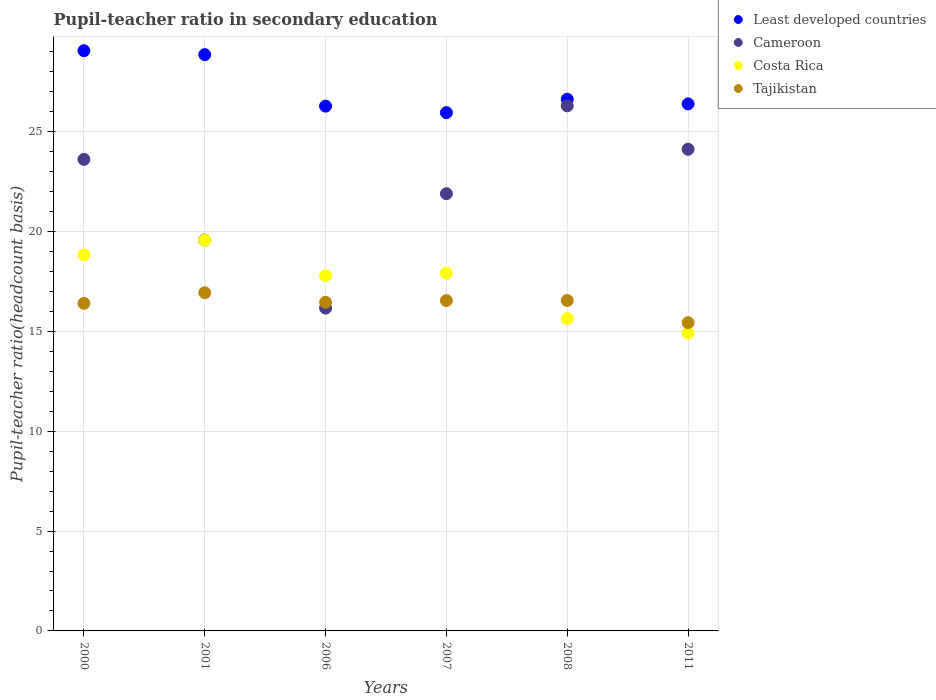What is the pupil-teacher ratio in secondary education in Least developed countries in 2006?
Give a very brief answer. 26.28. Across all years, what is the maximum pupil-teacher ratio in secondary education in Costa Rica?
Your answer should be compact. 19.57. Across all years, what is the minimum pupil-teacher ratio in secondary education in Tajikistan?
Provide a short and direct response. 15.44. In which year was the pupil-teacher ratio in secondary education in Least developed countries maximum?
Ensure brevity in your answer.  2000. In which year was the pupil-teacher ratio in secondary education in Tajikistan minimum?
Make the answer very short. 2011. What is the total pupil-teacher ratio in secondary education in Cameroon in the graph?
Your answer should be compact. 131.69. What is the difference between the pupil-teacher ratio in secondary education in Tajikistan in 2000 and that in 2001?
Give a very brief answer. -0.53. What is the difference between the pupil-teacher ratio in secondary education in Costa Rica in 2011 and the pupil-teacher ratio in secondary education in Cameroon in 2000?
Your answer should be compact. -8.7. What is the average pupil-teacher ratio in secondary education in Tajikistan per year?
Provide a succinct answer. 16.39. In the year 2008, what is the difference between the pupil-teacher ratio in secondary education in Least developed countries and pupil-teacher ratio in secondary education in Tajikistan?
Give a very brief answer. 10.08. In how many years, is the pupil-teacher ratio in secondary education in Cameroon greater than 12?
Give a very brief answer. 6. What is the ratio of the pupil-teacher ratio in secondary education in Tajikistan in 2000 to that in 2006?
Make the answer very short. 1. Is the pupil-teacher ratio in secondary education in Tajikistan in 2006 less than that in 2008?
Ensure brevity in your answer.  Yes. What is the difference between the highest and the second highest pupil-teacher ratio in secondary education in Tajikistan?
Your response must be concise. 0.39. What is the difference between the highest and the lowest pupil-teacher ratio in secondary education in Least developed countries?
Your answer should be very brief. 3.1. In how many years, is the pupil-teacher ratio in secondary education in Tajikistan greater than the average pupil-teacher ratio in secondary education in Tajikistan taken over all years?
Your answer should be very brief. 5. Is the pupil-teacher ratio in secondary education in Cameroon strictly greater than the pupil-teacher ratio in secondary education in Least developed countries over the years?
Ensure brevity in your answer.  No. How many dotlines are there?
Your response must be concise. 4. What is the difference between two consecutive major ticks on the Y-axis?
Your answer should be compact. 5. Does the graph contain grids?
Your answer should be very brief. Yes. Where does the legend appear in the graph?
Offer a terse response. Top right. What is the title of the graph?
Make the answer very short. Pupil-teacher ratio in secondary education. What is the label or title of the X-axis?
Make the answer very short. Years. What is the label or title of the Y-axis?
Your response must be concise. Pupil-teacher ratio(headcount basis). What is the Pupil-teacher ratio(headcount basis) of Least developed countries in 2000?
Offer a terse response. 29.06. What is the Pupil-teacher ratio(headcount basis) of Cameroon in 2000?
Keep it short and to the point. 23.62. What is the Pupil-teacher ratio(headcount basis) of Costa Rica in 2000?
Ensure brevity in your answer.  18.84. What is the Pupil-teacher ratio(headcount basis) in Tajikistan in 2000?
Offer a very short reply. 16.41. What is the Pupil-teacher ratio(headcount basis) in Least developed countries in 2001?
Make the answer very short. 28.86. What is the Pupil-teacher ratio(headcount basis) of Cameroon in 2001?
Your response must be concise. 19.58. What is the Pupil-teacher ratio(headcount basis) in Costa Rica in 2001?
Keep it short and to the point. 19.57. What is the Pupil-teacher ratio(headcount basis) of Tajikistan in 2001?
Provide a short and direct response. 16.94. What is the Pupil-teacher ratio(headcount basis) of Least developed countries in 2006?
Offer a very short reply. 26.28. What is the Pupil-teacher ratio(headcount basis) of Cameroon in 2006?
Provide a short and direct response. 16.17. What is the Pupil-teacher ratio(headcount basis) in Costa Rica in 2006?
Your answer should be very brief. 17.79. What is the Pupil-teacher ratio(headcount basis) in Tajikistan in 2006?
Your answer should be very brief. 16.46. What is the Pupil-teacher ratio(headcount basis) of Least developed countries in 2007?
Offer a terse response. 25.96. What is the Pupil-teacher ratio(headcount basis) of Cameroon in 2007?
Your answer should be very brief. 21.9. What is the Pupil-teacher ratio(headcount basis) in Costa Rica in 2007?
Provide a short and direct response. 17.91. What is the Pupil-teacher ratio(headcount basis) of Tajikistan in 2007?
Provide a succinct answer. 16.54. What is the Pupil-teacher ratio(headcount basis) of Least developed countries in 2008?
Provide a succinct answer. 26.63. What is the Pupil-teacher ratio(headcount basis) of Cameroon in 2008?
Offer a terse response. 26.3. What is the Pupil-teacher ratio(headcount basis) in Costa Rica in 2008?
Your response must be concise. 15.64. What is the Pupil-teacher ratio(headcount basis) of Tajikistan in 2008?
Your answer should be very brief. 16.55. What is the Pupil-teacher ratio(headcount basis) in Least developed countries in 2011?
Make the answer very short. 26.4. What is the Pupil-teacher ratio(headcount basis) in Cameroon in 2011?
Your answer should be very brief. 24.13. What is the Pupil-teacher ratio(headcount basis) in Costa Rica in 2011?
Your answer should be compact. 14.92. What is the Pupil-teacher ratio(headcount basis) of Tajikistan in 2011?
Keep it short and to the point. 15.44. Across all years, what is the maximum Pupil-teacher ratio(headcount basis) of Least developed countries?
Provide a succinct answer. 29.06. Across all years, what is the maximum Pupil-teacher ratio(headcount basis) of Cameroon?
Offer a terse response. 26.3. Across all years, what is the maximum Pupil-teacher ratio(headcount basis) of Costa Rica?
Make the answer very short. 19.57. Across all years, what is the maximum Pupil-teacher ratio(headcount basis) of Tajikistan?
Give a very brief answer. 16.94. Across all years, what is the minimum Pupil-teacher ratio(headcount basis) in Least developed countries?
Provide a succinct answer. 25.96. Across all years, what is the minimum Pupil-teacher ratio(headcount basis) of Cameroon?
Your response must be concise. 16.17. Across all years, what is the minimum Pupil-teacher ratio(headcount basis) in Costa Rica?
Provide a short and direct response. 14.92. Across all years, what is the minimum Pupil-teacher ratio(headcount basis) of Tajikistan?
Your answer should be very brief. 15.44. What is the total Pupil-teacher ratio(headcount basis) of Least developed countries in the graph?
Your answer should be compact. 163.2. What is the total Pupil-teacher ratio(headcount basis) in Cameroon in the graph?
Offer a very short reply. 131.69. What is the total Pupil-teacher ratio(headcount basis) in Costa Rica in the graph?
Provide a short and direct response. 104.68. What is the total Pupil-teacher ratio(headcount basis) in Tajikistan in the graph?
Your response must be concise. 98.34. What is the difference between the Pupil-teacher ratio(headcount basis) of Least developed countries in 2000 and that in 2001?
Your answer should be very brief. 0.2. What is the difference between the Pupil-teacher ratio(headcount basis) of Cameroon in 2000 and that in 2001?
Provide a succinct answer. 4.04. What is the difference between the Pupil-teacher ratio(headcount basis) in Costa Rica in 2000 and that in 2001?
Offer a terse response. -0.73. What is the difference between the Pupil-teacher ratio(headcount basis) in Tajikistan in 2000 and that in 2001?
Provide a succinct answer. -0.53. What is the difference between the Pupil-teacher ratio(headcount basis) in Least developed countries in 2000 and that in 2006?
Offer a very short reply. 2.78. What is the difference between the Pupil-teacher ratio(headcount basis) in Cameroon in 2000 and that in 2006?
Your answer should be very brief. 7.45. What is the difference between the Pupil-teacher ratio(headcount basis) in Costa Rica in 2000 and that in 2006?
Your answer should be compact. 1.05. What is the difference between the Pupil-teacher ratio(headcount basis) of Tajikistan in 2000 and that in 2006?
Provide a succinct answer. -0.05. What is the difference between the Pupil-teacher ratio(headcount basis) of Least developed countries in 2000 and that in 2007?
Make the answer very short. 3.1. What is the difference between the Pupil-teacher ratio(headcount basis) in Cameroon in 2000 and that in 2007?
Your answer should be compact. 1.72. What is the difference between the Pupil-teacher ratio(headcount basis) of Costa Rica in 2000 and that in 2007?
Keep it short and to the point. 0.93. What is the difference between the Pupil-teacher ratio(headcount basis) in Tajikistan in 2000 and that in 2007?
Your response must be concise. -0.14. What is the difference between the Pupil-teacher ratio(headcount basis) in Least developed countries in 2000 and that in 2008?
Ensure brevity in your answer.  2.43. What is the difference between the Pupil-teacher ratio(headcount basis) of Cameroon in 2000 and that in 2008?
Offer a very short reply. -2.68. What is the difference between the Pupil-teacher ratio(headcount basis) in Costa Rica in 2000 and that in 2008?
Make the answer very short. 3.2. What is the difference between the Pupil-teacher ratio(headcount basis) of Tajikistan in 2000 and that in 2008?
Provide a short and direct response. -0.14. What is the difference between the Pupil-teacher ratio(headcount basis) of Least developed countries in 2000 and that in 2011?
Make the answer very short. 2.66. What is the difference between the Pupil-teacher ratio(headcount basis) of Cameroon in 2000 and that in 2011?
Your response must be concise. -0.51. What is the difference between the Pupil-teacher ratio(headcount basis) of Costa Rica in 2000 and that in 2011?
Your answer should be compact. 3.92. What is the difference between the Pupil-teacher ratio(headcount basis) of Tajikistan in 2000 and that in 2011?
Provide a succinct answer. 0.97. What is the difference between the Pupil-teacher ratio(headcount basis) in Least developed countries in 2001 and that in 2006?
Your answer should be compact. 2.58. What is the difference between the Pupil-teacher ratio(headcount basis) of Cameroon in 2001 and that in 2006?
Keep it short and to the point. 3.41. What is the difference between the Pupil-teacher ratio(headcount basis) in Costa Rica in 2001 and that in 2006?
Provide a short and direct response. 1.78. What is the difference between the Pupil-teacher ratio(headcount basis) in Tajikistan in 2001 and that in 2006?
Provide a succinct answer. 0.48. What is the difference between the Pupil-teacher ratio(headcount basis) in Least developed countries in 2001 and that in 2007?
Make the answer very short. 2.9. What is the difference between the Pupil-teacher ratio(headcount basis) in Cameroon in 2001 and that in 2007?
Make the answer very short. -2.32. What is the difference between the Pupil-teacher ratio(headcount basis) of Costa Rica in 2001 and that in 2007?
Offer a very short reply. 1.66. What is the difference between the Pupil-teacher ratio(headcount basis) of Tajikistan in 2001 and that in 2007?
Ensure brevity in your answer.  0.4. What is the difference between the Pupil-teacher ratio(headcount basis) of Least developed countries in 2001 and that in 2008?
Give a very brief answer. 2.23. What is the difference between the Pupil-teacher ratio(headcount basis) of Cameroon in 2001 and that in 2008?
Provide a succinct answer. -6.72. What is the difference between the Pupil-teacher ratio(headcount basis) in Costa Rica in 2001 and that in 2008?
Ensure brevity in your answer.  3.93. What is the difference between the Pupil-teacher ratio(headcount basis) of Tajikistan in 2001 and that in 2008?
Give a very brief answer. 0.39. What is the difference between the Pupil-teacher ratio(headcount basis) of Least developed countries in 2001 and that in 2011?
Provide a short and direct response. 2.47. What is the difference between the Pupil-teacher ratio(headcount basis) of Cameroon in 2001 and that in 2011?
Offer a very short reply. -4.55. What is the difference between the Pupil-teacher ratio(headcount basis) of Costa Rica in 2001 and that in 2011?
Your response must be concise. 4.65. What is the difference between the Pupil-teacher ratio(headcount basis) in Tajikistan in 2001 and that in 2011?
Offer a very short reply. 1.5. What is the difference between the Pupil-teacher ratio(headcount basis) in Least developed countries in 2006 and that in 2007?
Your answer should be very brief. 0.33. What is the difference between the Pupil-teacher ratio(headcount basis) of Cameroon in 2006 and that in 2007?
Offer a very short reply. -5.73. What is the difference between the Pupil-teacher ratio(headcount basis) of Costa Rica in 2006 and that in 2007?
Offer a terse response. -0.12. What is the difference between the Pupil-teacher ratio(headcount basis) of Tajikistan in 2006 and that in 2007?
Offer a terse response. -0.09. What is the difference between the Pupil-teacher ratio(headcount basis) of Least developed countries in 2006 and that in 2008?
Your answer should be compact. -0.35. What is the difference between the Pupil-teacher ratio(headcount basis) of Cameroon in 2006 and that in 2008?
Your response must be concise. -10.13. What is the difference between the Pupil-teacher ratio(headcount basis) of Costa Rica in 2006 and that in 2008?
Ensure brevity in your answer.  2.15. What is the difference between the Pupil-teacher ratio(headcount basis) of Tajikistan in 2006 and that in 2008?
Your answer should be very brief. -0.09. What is the difference between the Pupil-teacher ratio(headcount basis) in Least developed countries in 2006 and that in 2011?
Your answer should be compact. -0.11. What is the difference between the Pupil-teacher ratio(headcount basis) in Cameroon in 2006 and that in 2011?
Make the answer very short. -7.96. What is the difference between the Pupil-teacher ratio(headcount basis) of Costa Rica in 2006 and that in 2011?
Keep it short and to the point. 2.87. What is the difference between the Pupil-teacher ratio(headcount basis) of Least developed countries in 2007 and that in 2008?
Your response must be concise. -0.67. What is the difference between the Pupil-teacher ratio(headcount basis) of Cameroon in 2007 and that in 2008?
Make the answer very short. -4.4. What is the difference between the Pupil-teacher ratio(headcount basis) of Costa Rica in 2007 and that in 2008?
Offer a very short reply. 2.27. What is the difference between the Pupil-teacher ratio(headcount basis) of Tajikistan in 2007 and that in 2008?
Give a very brief answer. -0.01. What is the difference between the Pupil-teacher ratio(headcount basis) of Least developed countries in 2007 and that in 2011?
Offer a very short reply. -0.44. What is the difference between the Pupil-teacher ratio(headcount basis) in Cameroon in 2007 and that in 2011?
Provide a short and direct response. -2.23. What is the difference between the Pupil-teacher ratio(headcount basis) in Costa Rica in 2007 and that in 2011?
Offer a very short reply. 2.99. What is the difference between the Pupil-teacher ratio(headcount basis) of Tajikistan in 2007 and that in 2011?
Keep it short and to the point. 1.11. What is the difference between the Pupil-teacher ratio(headcount basis) in Least developed countries in 2008 and that in 2011?
Your response must be concise. 0.23. What is the difference between the Pupil-teacher ratio(headcount basis) in Cameroon in 2008 and that in 2011?
Make the answer very short. 2.18. What is the difference between the Pupil-teacher ratio(headcount basis) of Costa Rica in 2008 and that in 2011?
Provide a succinct answer. 0.72. What is the difference between the Pupil-teacher ratio(headcount basis) of Tajikistan in 2008 and that in 2011?
Your answer should be very brief. 1.11. What is the difference between the Pupil-teacher ratio(headcount basis) of Least developed countries in 2000 and the Pupil-teacher ratio(headcount basis) of Cameroon in 2001?
Give a very brief answer. 9.48. What is the difference between the Pupil-teacher ratio(headcount basis) in Least developed countries in 2000 and the Pupil-teacher ratio(headcount basis) in Costa Rica in 2001?
Offer a very short reply. 9.49. What is the difference between the Pupil-teacher ratio(headcount basis) of Least developed countries in 2000 and the Pupil-teacher ratio(headcount basis) of Tajikistan in 2001?
Ensure brevity in your answer.  12.12. What is the difference between the Pupil-teacher ratio(headcount basis) of Cameroon in 2000 and the Pupil-teacher ratio(headcount basis) of Costa Rica in 2001?
Ensure brevity in your answer.  4.05. What is the difference between the Pupil-teacher ratio(headcount basis) of Cameroon in 2000 and the Pupil-teacher ratio(headcount basis) of Tajikistan in 2001?
Keep it short and to the point. 6.68. What is the difference between the Pupil-teacher ratio(headcount basis) in Costa Rica in 2000 and the Pupil-teacher ratio(headcount basis) in Tajikistan in 2001?
Give a very brief answer. 1.9. What is the difference between the Pupil-teacher ratio(headcount basis) in Least developed countries in 2000 and the Pupil-teacher ratio(headcount basis) in Cameroon in 2006?
Ensure brevity in your answer.  12.89. What is the difference between the Pupil-teacher ratio(headcount basis) of Least developed countries in 2000 and the Pupil-teacher ratio(headcount basis) of Costa Rica in 2006?
Your response must be concise. 11.27. What is the difference between the Pupil-teacher ratio(headcount basis) of Least developed countries in 2000 and the Pupil-teacher ratio(headcount basis) of Tajikistan in 2006?
Your response must be concise. 12.6. What is the difference between the Pupil-teacher ratio(headcount basis) in Cameroon in 2000 and the Pupil-teacher ratio(headcount basis) in Costa Rica in 2006?
Make the answer very short. 5.82. What is the difference between the Pupil-teacher ratio(headcount basis) in Cameroon in 2000 and the Pupil-teacher ratio(headcount basis) in Tajikistan in 2006?
Offer a terse response. 7.16. What is the difference between the Pupil-teacher ratio(headcount basis) in Costa Rica in 2000 and the Pupil-teacher ratio(headcount basis) in Tajikistan in 2006?
Your response must be concise. 2.38. What is the difference between the Pupil-teacher ratio(headcount basis) in Least developed countries in 2000 and the Pupil-teacher ratio(headcount basis) in Cameroon in 2007?
Provide a short and direct response. 7.16. What is the difference between the Pupil-teacher ratio(headcount basis) in Least developed countries in 2000 and the Pupil-teacher ratio(headcount basis) in Costa Rica in 2007?
Provide a short and direct response. 11.15. What is the difference between the Pupil-teacher ratio(headcount basis) of Least developed countries in 2000 and the Pupil-teacher ratio(headcount basis) of Tajikistan in 2007?
Your answer should be compact. 12.52. What is the difference between the Pupil-teacher ratio(headcount basis) in Cameroon in 2000 and the Pupil-teacher ratio(headcount basis) in Costa Rica in 2007?
Keep it short and to the point. 5.71. What is the difference between the Pupil-teacher ratio(headcount basis) in Cameroon in 2000 and the Pupil-teacher ratio(headcount basis) in Tajikistan in 2007?
Your answer should be very brief. 7.07. What is the difference between the Pupil-teacher ratio(headcount basis) of Costa Rica in 2000 and the Pupil-teacher ratio(headcount basis) of Tajikistan in 2007?
Make the answer very short. 2.3. What is the difference between the Pupil-teacher ratio(headcount basis) of Least developed countries in 2000 and the Pupil-teacher ratio(headcount basis) of Cameroon in 2008?
Make the answer very short. 2.76. What is the difference between the Pupil-teacher ratio(headcount basis) of Least developed countries in 2000 and the Pupil-teacher ratio(headcount basis) of Costa Rica in 2008?
Keep it short and to the point. 13.42. What is the difference between the Pupil-teacher ratio(headcount basis) of Least developed countries in 2000 and the Pupil-teacher ratio(headcount basis) of Tajikistan in 2008?
Provide a succinct answer. 12.51. What is the difference between the Pupil-teacher ratio(headcount basis) in Cameroon in 2000 and the Pupil-teacher ratio(headcount basis) in Costa Rica in 2008?
Your answer should be compact. 7.98. What is the difference between the Pupil-teacher ratio(headcount basis) of Cameroon in 2000 and the Pupil-teacher ratio(headcount basis) of Tajikistan in 2008?
Give a very brief answer. 7.07. What is the difference between the Pupil-teacher ratio(headcount basis) in Costa Rica in 2000 and the Pupil-teacher ratio(headcount basis) in Tajikistan in 2008?
Make the answer very short. 2.29. What is the difference between the Pupil-teacher ratio(headcount basis) in Least developed countries in 2000 and the Pupil-teacher ratio(headcount basis) in Cameroon in 2011?
Provide a short and direct response. 4.94. What is the difference between the Pupil-teacher ratio(headcount basis) of Least developed countries in 2000 and the Pupil-teacher ratio(headcount basis) of Costa Rica in 2011?
Ensure brevity in your answer.  14.14. What is the difference between the Pupil-teacher ratio(headcount basis) in Least developed countries in 2000 and the Pupil-teacher ratio(headcount basis) in Tajikistan in 2011?
Provide a short and direct response. 13.62. What is the difference between the Pupil-teacher ratio(headcount basis) in Cameroon in 2000 and the Pupil-teacher ratio(headcount basis) in Costa Rica in 2011?
Make the answer very short. 8.7. What is the difference between the Pupil-teacher ratio(headcount basis) of Cameroon in 2000 and the Pupil-teacher ratio(headcount basis) of Tajikistan in 2011?
Offer a terse response. 8.18. What is the difference between the Pupil-teacher ratio(headcount basis) of Costa Rica in 2000 and the Pupil-teacher ratio(headcount basis) of Tajikistan in 2011?
Provide a short and direct response. 3.4. What is the difference between the Pupil-teacher ratio(headcount basis) of Least developed countries in 2001 and the Pupil-teacher ratio(headcount basis) of Cameroon in 2006?
Your answer should be compact. 12.69. What is the difference between the Pupil-teacher ratio(headcount basis) in Least developed countries in 2001 and the Pupil-teacher ratio(headcount basis) in Costa Rica in 2006?
Your answer should be compact. 11.07. What is the difference between the Pupil-teacher ratio(headcount basis) of Least developed countries in 2001 and the Pupil-teacher ratio(headcount basis) of Tajikistan in 2006?
Give a very brief answer. 12.41. What is the difference between the Pupil-teacher ratio(headcount basis) of Cameroon in 2001 and the Pupil-teacher ratio(headcount basis) of Costa Rica in 2006?
Ensure brevity in your answer.  1.78. What is the difference between the Pupil-teacher ratio(headcount basis) in Cameroon in 2001 and the Pupil-teacher ratio(headcount basis) in Tajikistan in 2006?
Keep it short and to the point. 3.12. What is the difference between the Pupil-teacher ratio(headcount basis) of Costa Rica in 2001 and the Pupil-teacher ratio(headcount basis) of Tajikistan in 2006?
Offer a terse response. 3.11. What is the difference between the Pupil-teacher ratio(headcount basis) of Least developed countries in 2001 and the Pupil-teacher ratio(headcount basis) of Cameroon in 2007?
Ensure brevity in your answer.  6.97. What is the difference between the Pupil-teacher ratio(headcount basis) in Least developed countries in 2001 and the Pupil-teacher ratio(headcount basis) in Costa Rica in 2007?
Ensure brevity in your answer.  10.95. What is the difference between the Pupil-teacher ratio(headcount basis) in Least developed countries in 2001 and the Pupil-teacher ratio(headcount basis) in Tajikistan in 2007?
Offer a very short reply. 12.32. What is the difference between the Pupil-teacher ratio(headcount basis) of Cameroon in 2001 and the Pupil-teacher ratio(headcount basis) of Costa Rica in 2007?
Offer a terse response. 1.67. What is the difference between the Pupil-teacher ratio(headcount basis) of Cameroon in 2001 and the Pupil-teacher ratio(headcount basis) of Tajikistan in 2007?
Provide a succinct answer. 3.03. What is the difference between the Pupil-teacher ratio(headcount basis) of Costa Rica in 2001 and the Pupil-teacher ratio(headcount basis) of Tajikistan in 2007?
Your answer should be compact. 3.03. What is the difference between the Pupil-teacher ratio(headcount basis) of Least developed countries in 2001 and the Pupil-teacher ratio(headcount basis) of Cameroon in 2008?
Provide a short and direct response. 2.56. What is the difference between the Pupil-teacher ratio(headcount basis) in Least developed countries in 2001 and the Pupil-teacher ratio(headcount basis) in Costa Rica in 2008?
Your response must be concise. 13.22. What is the difference between the Pupil-teacher ratio(headcount basis) of Least developed countries in 2001 and the Pupil-teacher ratio(headcount basis) of Tajikistan in 2008?
Your answer should be very brief. 12.31. What is the difference between the Pupil-teacher ratio(headcount basis) of Cameroon in 2001 and the Pupil-teacher ratio(headcount basis) of Costa Rica in 2008?
Ensure brevity in your answer.  3.94. What is the difference between the Pupil-teacher ratio(headcount basis) of Cameroon in 2001 and the Pupil-teacher ratio(headcount basis) of Tajikistan in 2008?
Offer a terse response. 3.03. What is the difference between the Pupil-teacher ratio(headcount basis) of Costa Rica in 2001 and the Pupil-teacher ratio(headcount basis) of Tajikistan in 2008?
Provide a short and direct response. 3.02. What is the difference between the Pupil-teacher ratio(headcount basis) in Least developed countries in 2001 and the Pupil-teacher ratio(headcount basis) in Cameroon in 2011?
Provide a succinct answer. 4.74. What is the difference between the Pupil-teacher ratio(headcount basis) in Least developed countries in 2001 and the Pupil-teacher ratio(headcount basis) in Costa Rica in 2011?
Your response must be concise. 13.94. What is the difference between the Pupil-teacher ratio(headcount basis) in Least developed countries in 2001 and the Pupil-teacher ratio(headcount basis) in Tajikistan in 2011?
Give a very brief answer. 13.43. What is the difference between the Pupil-teacher ratio(headcount basis) in Cameroon in 2001 and the Pupil-teacher ratio(headcount basis) in Costa Rica in 2011?
Provide a succinct answer. 4.66. What is the difference between the Pupil-teacher ratio(headcount basis) in Cameroon in 2001 and the Pupil-teacher ratio(headcount basis) in Tajikistan in 2011?
Your response must be concise. 4.14. What is the difference between the Pupil-teacher ratio(headcount basis) of Costa Rica in 2001 and the Pupil-teacher ratio(headcount basis) of Tajikistan in 2011?
Give a very brief answer. 4.13. What is the difference between the Pupil-teacher ratio(headcount basis) in Least developed countries in 2006 and the Pupil-teacher ratio(headcount basis) in Cameroon in 2007?
Ensure brevity in your answer.  4.39. What is the difference between the Pupil-teacher ratio(headcount basis) of Least developed countries in 2006 and the Pupil-teacher ratio(headcount basis) of Costa Rica in 2007?
Your answer should be very brief. 8.37. What is the difference between the Pupil-teacher ratio(headcount basis) in Least developed countries in 2006 and the Pupil-teacher ratio(headcount basis) in Tajikistan in 2007?
Ensure brevity in your answer.  9.74. What is the difference between the Pupil-teacher ratio(headcount basis) in Cameroon in 2006 and the Pupil-teacher ratio(headcount basis) in Costa Rica in 2007?
Your answer should be compact. -1.74. What is the difference between the Pupil-teacher ratio(headcount basis) in Cameroon in 2006 and the Pupil-teacher ratio(headcount basis) in Tajikistan in 2007?
Your response must be concise. -0.37. What is the difference between the Pupil-teacher ratio(headcount basis) of Costa Rica in 2006 and the Pupil-teacher ratio(headcount basis) of Tajikistan in 2007?
Make the answer very short. 1.25. What is the difference between the Pupil-teacher ratio(headcount basis) in Least developed countries in 2006 and the Pupil-teacher ratio(headcount basis) in Cameroon in 2008?
Offer a very short reply. -0.02. What is the difference between the Pupil-teacher ratio(headcount basis) of Least developed countries in 2006 and the Pupil-teacher ratio(headcount basis) of Costa Rica in 2008?
Offer a terse response. 10.64. What is the difference between the Pupil-teacher ratio(headcount basis) in Least developed countries in 2006 and the Pupil-teacher ratio(headcount basis) in Tajikistan in 2008?
Make the answer very short. 9.73. What is the difference between the Pupil-teacher ratio(headcount basis) in Cameroon in 2006 and the Pupil-teacher ratio(headcount basis) in Costa Rica in 2008?
Your answer should be very brief. 0.53. What is the difference between the Pupil-teacher ratio(headcount basis) of Cameroon in 2006 and the Pupil-teacher ratio(headcount basis) of Tajikistan in 2008?
Offer a very short reply. -0.38. What is the difference between the Pupil-teacher ratio(headcount basis) of Costa Rica in 2006 and the Pupil-teacher ratio(headcount basis) of Tajikistan in 2008?
Your response must be concise. 1.24. What is the difference between the Pupil-teacher ratio(headcount basis) in Least developed countries in 2006 and the Pupil-teacher ratio(headcount basis) in Cameroon in 2011?
Provide a short and direct response. 2.16. What is the difference between the Pupil-teacher ratio(headcount basis) of Least developed countries in 2006 and the Pupil-teacher ratio(headcount basis) of Costa Rica in 2011?
Your answer should be compact. 11.36. What is the difference between the Pupil-teacher ratio(headcount basis) of Least developed countries in 2006 and the Pupil-teacher ratio(headcount basis) of Tajikistan in 2011?
Provide a short and direct response. 10.85. What is the difference between the Pupil-teacher ratio(headcount basis) in Cameroon in 2006 and the Pupil-teacher ratio(headcount basis) in Costa Rica in 2011?
Your response must be concise. 1.25. What is the difference between the Pupil-teacher ratio(headcount basis) in Cameroon in 2006 and the Pupil-teacher ratio(headcount basis) in Tajikistan in 2011?
Keep it short and to the point. 0.73. What is the difference between the Pupil-teacher ratio(headcount basis) in Costa Rica in 2006 and the Pupil-teacher ratio(headcount basis) in Tajikistan in 2011?
Keep it short and to the point. 2.36. What is the difference between the Pupil-teacher ratio(headcount basis) in Least developed countries in 2007 and the Pupil-teacher ratio(headcount basis) in Cameroon in 2008?
Give a very brief answer. -0.34. What is the difference between the Pupil-teacher ratio(headcount basis) in Least developed countries in 2007 and the Pupil-teacher ratio(headcount basis) in Costa Rica in 2008?
Give a very brief answer. 10.32. What is the difference between the Pupil-teacher ratio(headcount basis) in Least developed countries in 2007 and the Pupil-teacher ratio(headcount basis) in Tajikistan in 2008?
Keep it short and to the point. 9.41. What is the difference between the Pupil-teacher ratio(headcount basis) of Cameroon in 2007 and the Pupil-teacher ratio(headcount basis) of Costa Rica in 2008?
Your response must be concise. 6.26. What is the difference between the Pupil-teacher ratio(headcount basis) of Cameroon in 2007 and the Pupil-teacher ratio(headcount basis) of Tajikistan in 2008?
Your answer should be compact. 5.35. What is the difference between the Pupil-teacher ratio(headcount basis) in Costa Rica in 2007 and the Pupil-teacher ratio(headcount basis) in Tajikistan in 2008?
Keep it short and to the point. 1.36. What is the difference between the Pupil-teacher ratio(headcount basis) of Least developed countries in 2007 and the Pupil-teacher ratio(headcount basis) of Cameroon in 2011?
Give a very brief answer. 1.83. What is the difference between the Pupil-teacher ratio(headcount basis) of Least developed countries in 2007 and the Pupil-teacher ratio(headcount basis) of Costa Rica in 2011?
Keep it short and to the point. 11.04. What is the difference between the Pupil-teacher ratio(headcount basis) of Least developed countries in 2007 and the Pupil-teacher ratio(headcount basis) of Tajikistan in 2011?
Give a very brief answer. 10.52. What is the difference between the Pupil-teacher ratio(headcount basis) in Cameroon in 2007 and the Pupil-teacher ratio(headcount basis) in Costa Rica in 2011?
Offer a terse response. 6.98. What is the difference between the Pupil-teacher ratio(headcount basis) in Cameroon in 2007 and the Pupil-teacher ratio(headcount basis) in Tajikistan in 2011?
Your answer should be compact. 6.46. What is the difference between the Pupil-teacher ratio(headcount basis) in Costa Rica in 2007 and the Pupil-teacher ratio(headcount basis) in Tajikistan in 2011?
Keep it short and to the point. 2.47. What is the difference between the Pupil-teacher ratio(headcount basis) in Least developed countries in 2008 and the Pupil-teacher ratio(headcount basis) in Cameroon in 2011?
Your answer should be compact. 2.5. What is the difference between the Pupil-teacher ratio(headcount basis) in Least developed countries in 2008 and the Pupil-teacher ratio(headcount basis) in Costa Rica in 2011?
Make the answer very short. 11.71. What is the difference between the Pupil-teacher ratio(headcount basis) in Least developed countries in 2008 and the Pupil-teacher ratio(headcount basis) in Tajikistan in 2011?
Offer a terse response. 11.19. What is the difference between the Pupil-teacher ratio(headcount basis) in Cameroon in 2008 and the Pupil-teacher ratio(headcount basis) in Costa Rica in 2011?
Offer a terse response. 11.38. What is the difference between the Pupil-teacher ratio(headcount basis) in Cameroon in 2008 and the Pupil-teacher ratio(headcount basis) in Tajikistan in 2011?
Keep it short and to the point. 10.86. What is the difference between the Pupil-teacher ratio(headcount basis) of Costa Rica in 2008 and the Pupil-teacher ratio(headcount basis) of Tajikistan in 2011?
Provide a succinct answer. 0.2. What is the average Pupil-teacher ratio(headcount basis) of Least developed countries per year?
Provide a short and direct response. 27.2. What is the average Pupil-teacher ratio(headcount basis) of Cameroon per year?
Give a very brief answer. 21.95. What is the average Pupil-teacher ratio(headcount basis) of Costa Rica per year?
Your answer should be compact. 17.45. What is the average Pupil-teacher ratio(headcount basis) in Tajikistan per year?
Keep it short and to the point. 16.39. In the year 2000, what is the difference between the Pupil-teacher ratio(headcount basis) of Least developed countries and Pupil-teacher ratio(headcount basis) of Cameroon?
Your response must be concise. 5.44. In the year 2000, what is the difference between the Pupil-teacher ratio(headcount basis) of Least developed countries and Pupil-teacher ratio(headcount basis) of Costa Rica?
Offer a very short reply. 10.22. In the year 2000, what is the difference between the Pupil-teacher ratio(headcount basis) in Least developed countries and Pupil-teacher ratio(headcount basis) in Tajikistan?
Keep it short and to the point. 12.66. In the year 2000, what is the difference between the Pupil-teacher ratio(headcount basis) in Cameroon and Pupil-teacher ratio(headcount basis) in Costa Rica?
Your response must be concise. 4.78. In the year 2000, what is the difference between the Pupil-teacher ratio(headcount basis) in Cameroon and Pupil-teacher ratio(headcount basis) in Tajikistan?
Keep it short and to the point. 7.21. In the year 2000, what is the difference between the Pupil-teacher ratio(headcount basis) in Costa Rica and Pupil-teacher ratio(headcount basis) in Tajikistan?
Your answer should be compact. 2.43. In the year 2001, what is the difference between the Pupil-teacher ratio(headcount basis) of Least developed countries and Pupil-teacher ratio(headcount basis) of Cameroon?
Make the answer very short. 9.29. In the year 2001, what is the difference between the Pupil-teacher ratio(headcount basis) of Least developed countries and Pupil-teacher ratio(headcount basis) of Costa Rica?
Your answer should be very brief. 9.29. In the year 2001, what is the difference between the Pupil-teacher ratio(headcount basis) of Least developed countries and Pupil-teacher ratio(headcount basis) of Tajikistan?
Your response must be concise. 11.92. In the year 2001, what is the difference between the Pupil-teacher ratio(headcount basis) in Cameroon and Pupil-teacher ratio(headcount basis) in Costa Rica?
Make the answer very short. 0.01. In the year 2001, what is the difference between the Pupil-teacher ratio(headcount basis) in Cameroon and Pupil-teacher ratio(headcount basis) in Tajikistan?
Provide a short and direct response. 2.64. In the year 2001, what is the difference between the Pupil-teacher ratio(headcount basis) of Costa Rica and Pupil-teacher ratio(headcount basis) of Tajikistan?
Ensure brevity in your answer.  2.63. In the year 2006, what is the difference between the Pupil-teacher ratio(headcount basis) in Least developed countries and Pupil-teacher ratio(headcount basis) in Cameroon?
Offer a terse response. 10.11. In the year 2006, what is the difference between the Pupil-teacher ratio(headcount basis) in Least developed countries and Pupil-teacher ratio(headcount basis) in Costa Rica?
Provide a short and direct response. 8.49. In the year 2006, what is the difference between the Pupil-teacher ratio(headcount basis) of Least developed countries and Pupil-teacher ratio(headcount basis) of Tajikistan?
Your answer should be compact. 9.83. In the year 2006, what is the difference between the Pupil-teacher ratio(headcount basis) in Cameroon and Pupil-teacher ratio(headcount basis) in Costa Rica?
Make the answer very short. -1.62. In the year 2006, what is the difference between the Pupil-teacher ratio(headcount basis) in Cameroon and Pupil-teacher ratio(headcount basis) in Tajikistan?
Provide a short and direct response. -0.29. In the year 2006, what is the difference between the Pupil-teacher ratio(headcount basis) of Costa Rica and Pupil-teacher ratio(headcount basis) of Tajikistan?
Your answer should be compact. 1.34. In the year 2007, what is the difference between the Pupil-teacher ratio(headcount basis) of Least developed countries and Pupil-teacher ratio(headcount basis) of Cameroon?
Make the answer very short. 4.06. In the year 2007, what is the difference between the Pupil-teacher ratio(headcount basis) of Least developed countries and Pupil-teacher ratio(headcount basis) of Costa Rica?
Provide a succinct answer. 8.05. In the year 2007, what is the difference between the Pupil-teacher ratio(headcount basis) of Least developed countries and Pupil-teacher ratio(headcount basis) of Tajikistan?
Offer a terse response. 9.42. In the year 2007, what is the difference between the Pupil-teacher ratio(headcount basis) of Cameroon and Pupil-teacher ratio(headcount basis) of Costa Rica?
Your answer should be very brief. 3.98. In the year 2007, what is the difference between the Pupil-teacher ratio(headcount basis) in Cameroon and Pupil-teacher ratio(headcount basis) in Tajikistan?
Give a very brief answer. 5.35. In the year 2007, what is the difference between the Pupil-teacher ratio(headcount basis) in Costa Rica and Pupil-teacher ratio(headcount basis) in Tajikistan?
Offer a very short reply. 1.37. In the year 2008, what is the difference between the Pupil-teacher ratio(headcount basis) of Least developed countries and Pupil-teacher ratio(headcount basis) of Cameroon?
Make the answer very short. 0.33. In the year 2008, what is the difference between the Pupil-teacher ratio(headcount basis) of Least developed countries and Pupil-teacher ratio(headcount basis) of Costa Rica?
Offer a very short reply. 10.99. In the year 2008, what is the difference between the Pupil-teacher ratio(headcount basis) of Least developed countries and Pupil-teacher ratio(headcount basis) of Tajikistan?
Ensure brevity in your answer.  10.08. In the year 2008, what is the difference between the Pupil-teacher ratio(headcount basis) of Cameroon and Pupil-teacher ratio(headcount basis) of Costa Rica?
Your response must be concise. 10.66. In the year 2008, what is the difference between the Pupil-teacher ratio(headcount basis) in Cameroon and Pupil-teacher ratio(headcount basis) in Tajikistan?
Your response must be concise. 9.75. In the year 2008, what is the difference between the Pupil-teacher ratio(headcount basis) of Costa Rica and Pupil-teacher ratio(headcount basis) of Tajikistan?
Provide a short and direct response. -0.91. In the year 2011, what is the difference between the Pupil-teacher ratio(headcount basis) in Least developed countries and Pupil-teacher ratio(headcount basis) in Cameroon?
Keep it short and to the point. 2.27. In the year 2011, what is the difference between the Pupil-teacher ratio(headcount basis) of Least developed countries and Pupil-teacher ratio(headcount basis) of Costa Rica?
Ensure brevity in your answer.  11.48. In the year 2011, what is the difference between the Pupil-teacher ratio(headcount basis) of Least developed countries and Pupil-teacher ratio(headcount basis) of Tajikistan?
Provide a succinct answer. 10.96. In the year 2011, what is the difference between the Pupil-teacher ratio(headcount basis) in Cameroon and Pupil-teacher ratio(headcount basis) in Costa Rica?
Offer a very short reply. 9.2. In the year 2011, what is the difference between the Pupil-teacher ratio(headcount basis) in Cameroon and Pupil-teacher ratio(headcount basis) in Tajikistan?
Provide a short and direct response. 8.69. In the year 2011, what is the difference between the Pupil-teacher ratio(headcount basis) of Costa Rica and Pupil-teacher ratio(headcount basis) of Tajikistan?
Offer a terse response. -0.52. What is the ratio of the Pupil-teacher ratio(headcount basis) of Least developed countries in 2000 to that in 2001?
Offer a terse response. 1.01. What is the ratio of the Pupil-teacher ratio(headcount basis) of Cameroon in 2000 to that in 2001?
Provide a succinct answer. 1.21. What is the ratio of the Pupil-teacher ratio(headcount basis) in Costa Rica in 2000 to that in 2001?
Make the answer very short. 0.96. What is the ratio of the Pupil-teacher ratio(headcount basis) in Tajikistan in 2000 to that in 2001?
Your answer should be very brief. 0.97. What is the ratio of the Pupil-teacher ratio(headcount basis) of Least developed countries in 2000 to that in 2006?
Your response must be concise. 1.11. What is the ratio of the Pupil-teacher ratio(headcount basis) in Cameroon in 2000 to that in 2006?
Provide a short and direct response. 1.46. What is the ratio of the Pupil-teacher ratio(headcount basis) of Costa Rica in 2000 to that in 2006?
Keep it short and to the point. 1.06. What is the ratio of the Pupil-teacher ratio(headcount basis) in Least developed countries in 2000 to that in 2007?
Keep it short and to the point. 1.12. What is the ratio of the Pupil-teacher ratio(headcount basis) of Cameroon in 2000 to that in 2007?
Offer a terse response. 1.08. What is the ratio of the Pupil-teacher ratio(headcount basis) of Costa Rica in 2000 to that in 2007?
Ensure brevity in your answer.  1.05. What is the ratio of the Pupil-teacher ratio(headcount basis) of Least developed countries in 2000 to that in 2008?
Your response must be concise. 1.09. What is the ratio of the Pupil-teacher ratio(headcount basis) of Cameroon in 2000 to that in 2008?
Offer a terse response. 0.9. What is the ratio of the Pupil-teacher ratio(headcount basis) in Costa Rica in 2000 to that in 2008?
Offer a very short reply. 1.2. What is the ratio of the Pupil-teacher ratio(headcount basis) of Least developed countries in 2000 to that in 2011?
Give a very brief answer. 1.1. What is the ratio of the Pupil-teacher ratio(headcount basis) in Cameroon in 2000 to that in 2011?
Your answer should be compact. 0.98. What is the ratio of the Pupil-teacher ratio(headcount basis) in Costa Rica in 2000 to that in 2011?
Your response must be concise. 1.26. What is the ratio of the Pupil-teacher ratio(headcount basis) in Tajikistan in 2000 to that in 2011?
Ensure brevity in your answer.  1.06. What is the ratio of the Pupil-teacher ratio(headcount basis) in Least developed countries in 2001 to that in 2006?
Offer a terse response. 1.1. What is the ratio of the Pupil-teacher ratio(headcount basis) of Cameroon in 2001 to that in 2006?
Your answer should be very brief. 1.21. What is the ratio of the Pupil-teacher ratio(headcount basis) of Costa Rica in 2001 to that in 2006?
Keep it short and to the point. 1.1. What is the ratio of the Pupil-teacher ratio(headcount basis) in Tajikistan in 2001 to that in 2006?
Provide a short and direct response. 1.03. What is the ratio of the Pupil-teacher ratio(headcount basis) of Least developed countries in 2001 to that in 2007?
Your answer should be very brief. 1.11. What is the ratio of the Pupil-teacher ratio(headcount basis) of Cameroon in 2001 to that in 2007?
Your answer should be very brief. 0.89. What is the ratio of the Pupil-teacher ratio(headcount basis) of Costa Rica in 2001 to that in 2007?
Offer a terse response. 1.09. What is the ratio of the Pupil-teacher ratio(headcount basis) of Tajikistan in 2001 to that in 2007?
Your answer should be compact. 1.02. What is the ratio of the Pupil-teacher ratio(headcount basis) in Least developed countries in 2001 to that in 2008?
Offer a very short reply. 1.08. What is the ratio of the Pupil-teacher ratio(headcount basis) in Cameroon in 2001 to that in 2008?
Your answer should be very brief. 0.74. What is the ratio of the Pupil-teacher ratio(headcount basis) in Costa Rica in 2001 to that in 2008?
Provide a short and direct response. 1.25. What is the ratio of the Pupil-teacher ratio(headcount basis) in Tajikistan in 2001 to that in 2008?
Give a very brief answer. 1.02. What is the ratio of the Pupil-teacher ratio(headcount basis) in Least developed countries in 2001 to that in 2011?
Your response must be concise. 1.09. What is the ratio of the Pupil-teacher ratio(headcount basis) in Cameroon in 2001 to that in 2011?
Provide a short and direct response. 0.81. What is the ratio of the Pupil-teacher ratio(headcount basis) in Costa Rica in 2001 to that in 2011?
Provide a succinct answer. 1.31. What is the ratio of the Pupil-teacher ratio(headcount basis) of Tajikistan in 2001 to that in 2011?
Give a very brief answer. 1.1. What is the ratio of the Pupil-teacher ratio(headcount basis) of Least developed countries in 2006 to that in 2007?
Offer a very short reply. 1.01. What is the ratio of the Pupil-teacher ratio(headcount basis) in Cameroon in 2006 to that in 2007?
Offer a terse response. 0.74. What is the ratio of the Pupil-teacher ratio(headcount basis) of Least developed countries in 2006 to that in 2008?
Your answer should be very brief. 0.99. What is the ratio of the Pupil-teacher ratio(headcount basis) in Cameroon in 2006 to that in 2008?
Offer a very short reply. 0.61. What is the ratio of the Pupil-teacher ratio(headcount basis) in Costa Rica in 2006 to that in 2008?
Give a very brief answer. 1.14. What is the ratio of the Pupil-teacher ratio(headcount basis) of Tajikistan in 2006 to that in 2008?
Offer a terse response. 0.99. What is the ratio of the Pupil-teacher ratio(headcount basis) in Least developed countries in 2006 to that in 2011?
Offer a terse response. 1. What is the ratio of the Pupil-teacher ratio(headcount basis) in Cameroon in 2006 to that in 2011?
Your response must be concise. 0.67. What is the ratio of the Pupil-teacher ratio(headcount basis) in Costa Rica in 2006 to that in 2011?
Offer a very short reply. 1.19. What is the ratio of the Pupil-teacher ratio(headcount basis) in Tajikistan in 2006 to that in 2011?
Offer a very short reply. 1.07. What is the ratio of the Pupil-teacher ratio(headcount basis) of Least developed countries in 2007 to that in 2008?
Your response must be concise. 0.97. What is the ratio of the Pupil-teacher ratio(headcount basis) of Cameroon in 2007 to that in 2008?
Make the answer very short. 0.83. What is the ratio of the Pupil-teacher ratio(headcount basis) in Costa Rica in 2007 to that in 2008?
Keep it short and to the point. 1.15. What is the ratio of the Pupil-teacher ratio(headcount basis) in Least developed countries in 2007 to that in 2011?
Offer a terse response. 0.98. What is the ratio of the Pupil-teacher ratio(headcount basis) in Cameroon in 2007 to that in 2011?
Keep it short and to the point. 0.91. What is the ratio of the Pupil-teacher ratio(headcount basis) in Costa Rica in 2007 to that in 2011?
Provide a short and direct response. 1.2. What is the ratio of the Pupil-teacher ratio(headcount basis) in Tajikistan in 2007 to that in 2011?
Provide a succinct answer. 1.07. What is the ratio of the Pupil-teacher ratio(headcount basis) in Least developed countries in 2008 to that in 2011?
Make the answer very short. 1.01. What is the ratio of the Pupil-teacher ratio(headcount basis) of Cameroon in 2008 to that in 2011?
Your answer should be compact. 1.09. What is the ratio of the Pupil-teacher ratio(headcount basis) of Costa Rica in 2008 to that in 2011?
Your answer should be compact. 1.05. What is the ratio of the Pupil-teacher ratio(headcount basis) of Tajikistan in 2008 to that in 2011?
Ensure brevity in your answer.  1.07. What is the difference between the highest and the second highest Pupil-teacher ratio(headcount basis) in Least developed countries?
Make the answer very short. 0.2. What is the difference between the highest and the second highest Pupil-teacher ratio(headcount basis) in Cameroon?
Keep it short and to the point. 2.18. What is the difference between the highest and the second highest Pupil-teacher ratio(headcount basis) of Costa Rica?
Offer a terse response. 0.73. What is the difference between the highest and the second highest Pupil-teacher ratio(headcount basis) of Tajikistan?
Ensure brevity in your answer.  0.39. What is the difference between the highest and the lowest Pupil-teacher ratio(headcount basis) in Least developed countries?
Make the answer very short. 3.1. What is the difference between the highest and the lowest Pupil-teacher ratio(headcount basis) in Cameroon?
Provide a short and direct response. 10.13. What is the difference between the highest and the lowest Pupil-teacher ratio(headcount basis) in Costa Rica?
Your response must be concise. 4.65. What is the difference between the highest and the lowest Pupil-teacher ratio(headcount basis) in Tajikistan?
Make the answer very short. 1.5. 